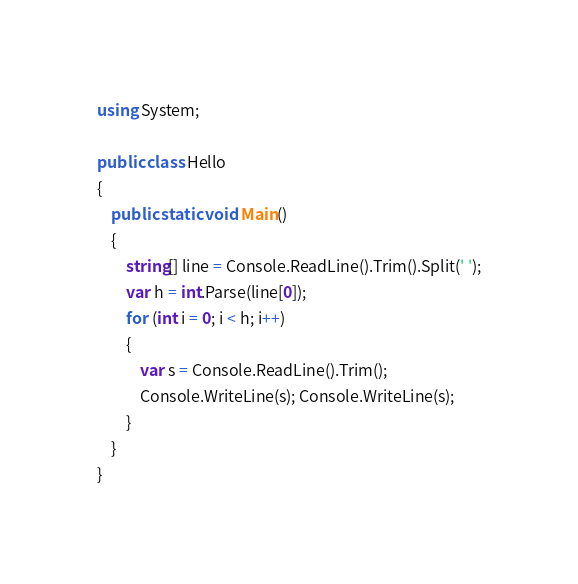<code> <loc_0><loc_0><loc_500><loc_500><_C#_>using System;

public class Hello
{
    public static void Main()
    {
        string[] line = Console.ReadLine().Trim().Split(' ');
        var h = int.Parse(line[0]);
        for (int i = 0; i < h; i++)
        {
            var s = Console.ReadLine().Trim();
            Console.WriteLine(s); Console.WriteLine(s);
        }
    }
}</code> 